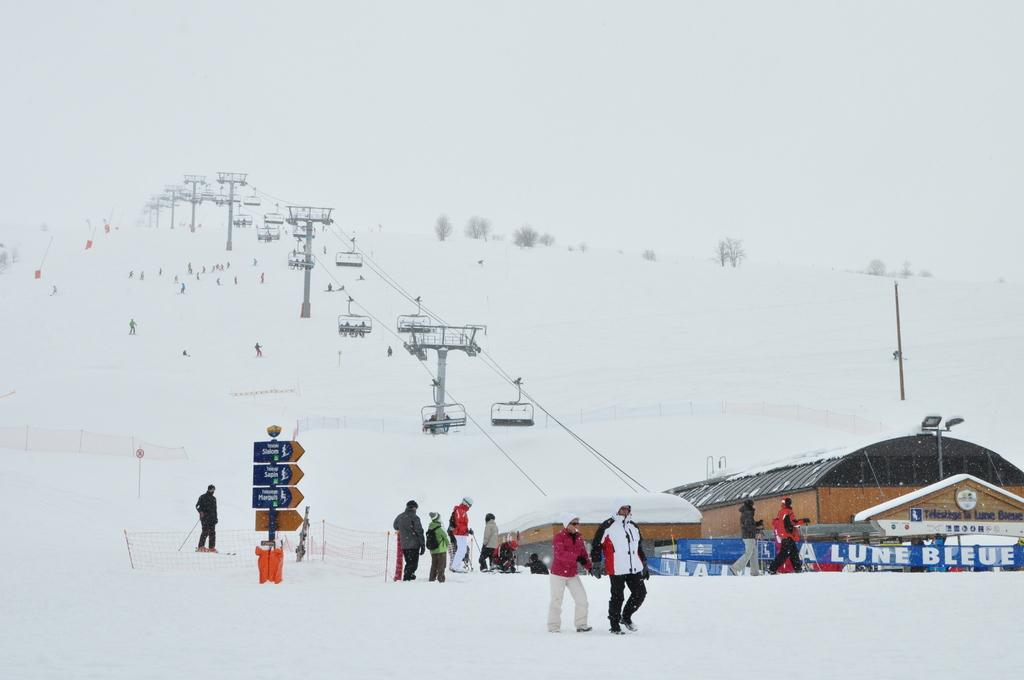How many people are in the image? There are persons in the image, but the exact number cannot be determined from the provided facts. What type of structure can be seen in the image? There is a mesh, boards, banners, a shed, and poles visible in the image. What is the weather like in the image? There is snow in the image, which suggests a cold or wintry environment. What type of transportation is present in the image? There are cable cars in the image. What type of vegetation is present in the image? There are trees in the image. What can be seen in the background of the image? The sky is visible in the background of the image. What is the opinion of the ornament about the zephyr in the image? There is no ornament or zephyr present in the image, so it is not possible to determine their opinions. 